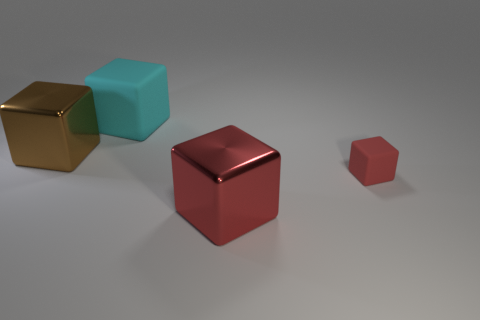Add 2 red metal cubes. How many objects exist? 6 Subtract 1 brown blocks. How many objects are left? 3 Subtract all big brown blocks. Subtract all small cubes. How many objects are left? 2 Add 3 tiny red blocks. How many tiny red blocks are left? 4 Add 3 large cyan blocks. How many large cyan blocks exist? 4 